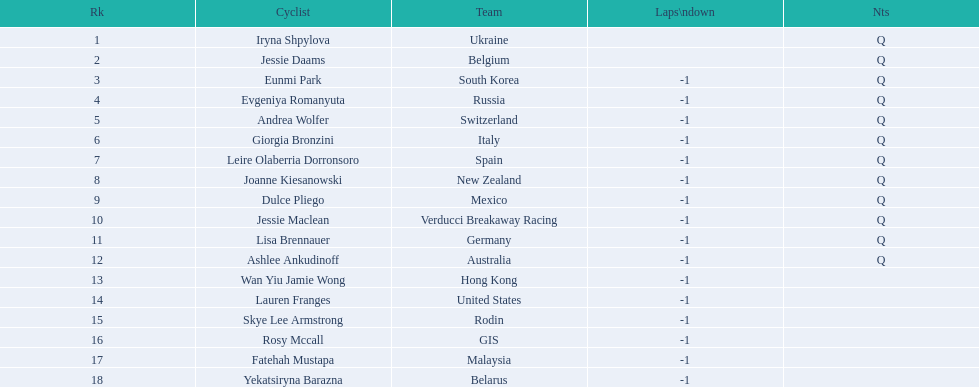How many cyclist do not have -1 laps down? 2. 